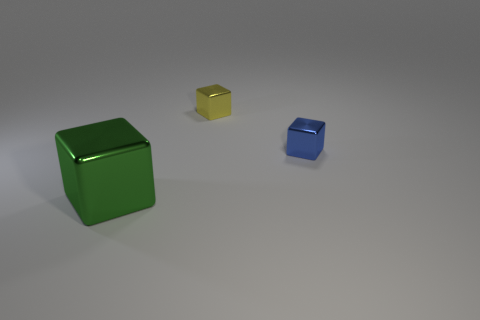Does the small shiny cube in front of the yellow block have the same color as the large cube? No, the small shiny cube in front of the yellow block does not share the same color as the large cube. The small cube is yellow, while the large cube is a rich green. 